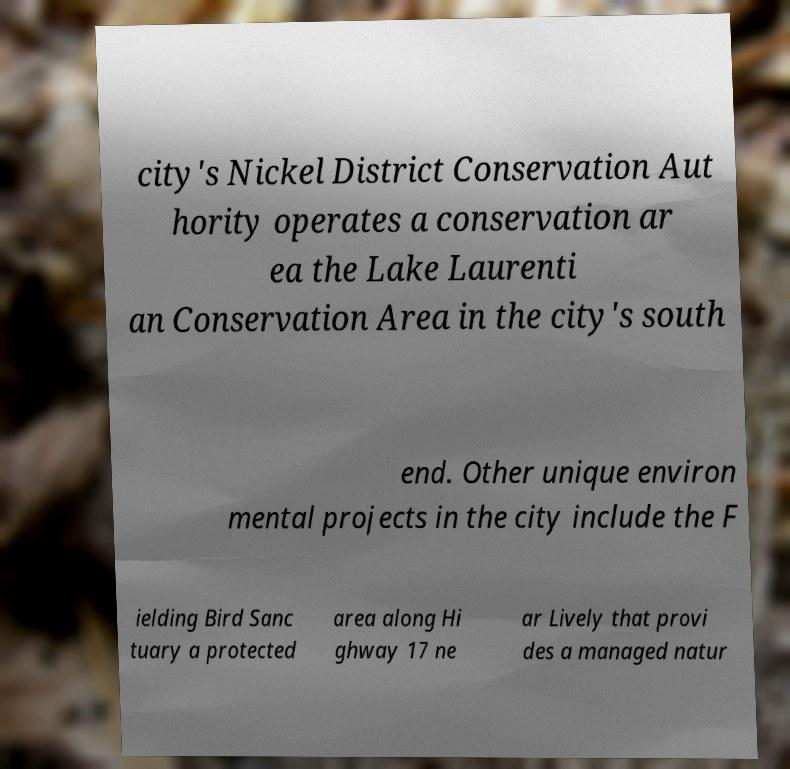Could you extract and type out the text from this image? city's Nickel District Conservation Aut hority operates a conservation ar ea the Lake Laurenti an Conservation Area in the city's south end. Other unique environ mental projects in the city include the F ielding Bird Sanc tuary a protected area along Hi ghway 17 ne ar Lively that provi des a managed natur 